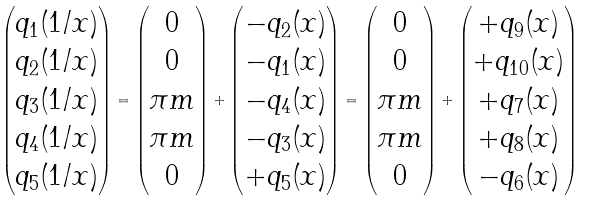<formula> <loc_0><loc_0><loc_500><loc_500>\begin{pmatrix} q _ { 1 } ( 1 / x ) \\ q _ { 2 } ( 1 / x ) \\ q _ { 3 } ( 1 / x ) \\ q _ { 4 } ( 1 / x ) \\ q _ { 5 } ( 1 / x ) \end{pmatrix} = \begin{pmatrix} 0 \\ 0 \\ \pi m \\ \pi m \\ 0 \end{pmatrix} + \begin{pmatrix} - q _ { 2 } ( x ) \\ - q _ { 1 } ( x ) \\ - q _ { 4 } ( x ) \\ - q _ { 3 } ( x ) \\ + q _ { 5 } ( x ) \end{pmatrix} = \begin{pmatrix} 0 \\ 0 \\ \pi m \\ \pi m \\ 0 \end{pmatrix} + \begin{pmatrix} + q _ { 9 } ( x ) \\ + q _ { 1 0 } ( x ) \\ + q _ { 7 } ( x ) \\ + q _ { 8 } ( x ) \\ - q _ { 6 } ( x ) \end{pmatrix}</formula> 